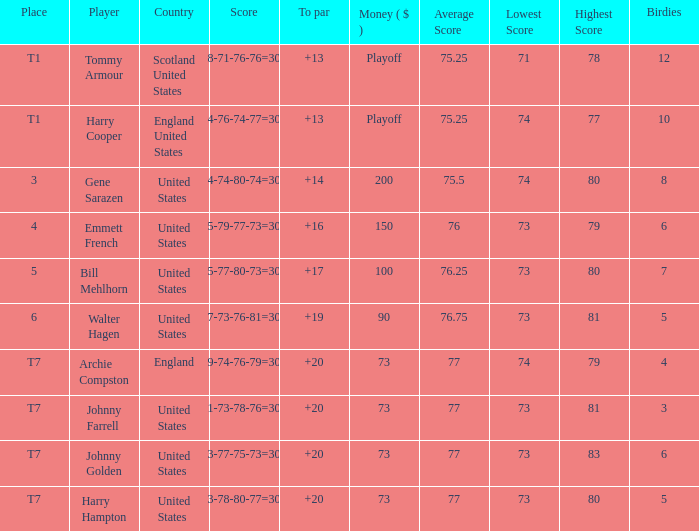What is the score for the United States when Harry Hampton is the player and the money is $73? 73-78-80-77=308. 